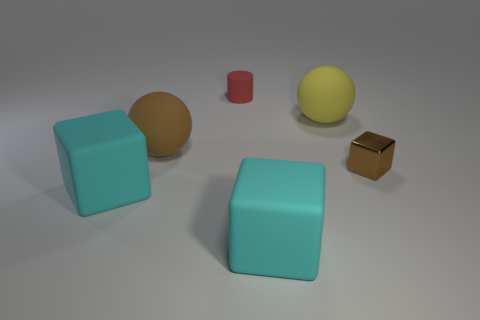Add 1 cylinders. How many objects exist? 7 Subtract all green blocks. Subtract all cyan balls. How many blocks are left? 3 Subtract all spheres. How many objects are left? 4 Subtract all big cyan metal cylinders. Subtract all brown matte things. How many objects are left? 5 Add 6 blocks. How many blocks are left? 9 Add 5 brown metal blocks. How many brown metal blocks exist? 6 Subtract 0 cyan balls. How many objects are left? 6 